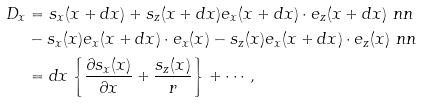Convert formula to latex. <formula><loc_0><loc_0><loc_500><loc_500>D _ { x } & = s _ { x } ( x + d x ) + s _ { z } ( x + d x ) { e } _ { x } ( x + d x ) \cdot { e } _ { z } ( x + d x ) \ n n \\ & - s _ { x } ( x ) { e } _ { x } ( x + d x ) \cdot { e } _ { x } ( x ) - s _ { z } ( x ) { e } _ { x } ( x + d x ) \cdot { e } _ { z } ( x ) \ n n \\ & = d x \left \{ \frac { \partial s _ { x } ( x ) } { \partial x } + \frac { s _ { z } ( x ) } { r } \right \} + \cdots ,</formula> 